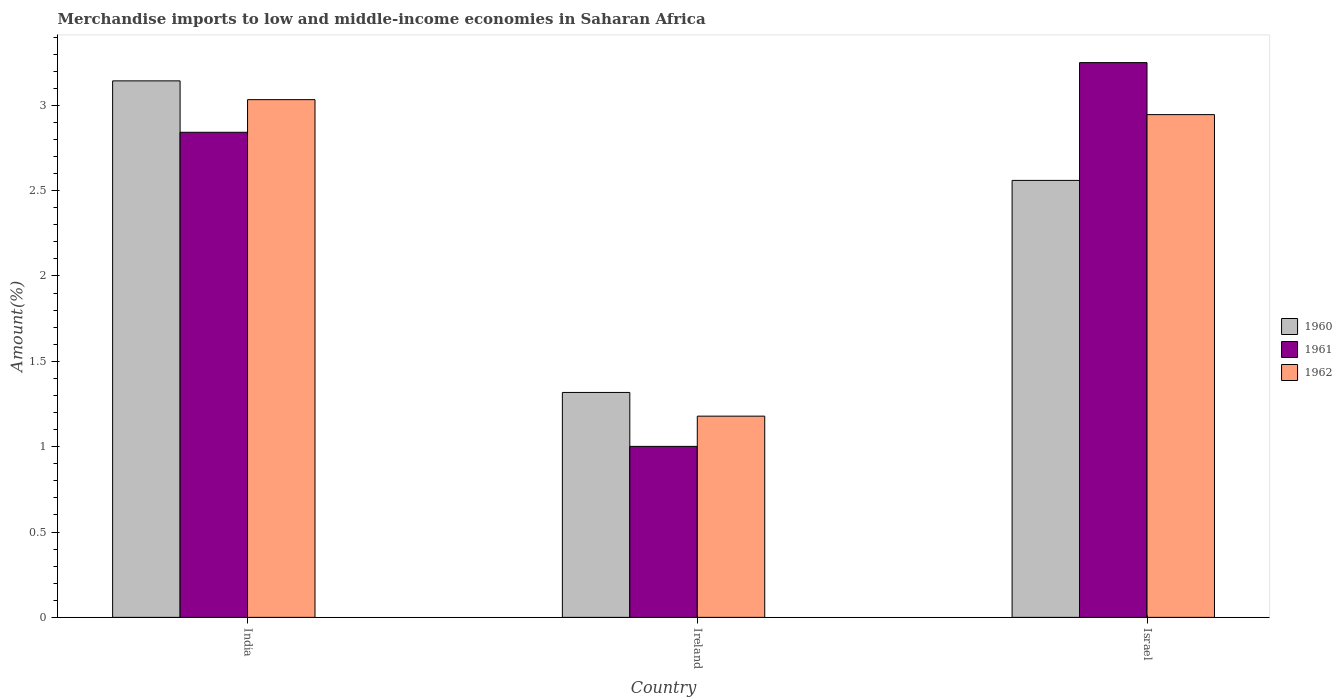How many groups of bars are there?
Offer a terse response. 3. Are the number of bars per tick equal to the number of legend labels?
Your answer should be very brief. Yes. Are the number of bars on each tick of the X-axis equal?
Ensure brevity in your answer.  Yes. How many bars are there on the 3rd tick from the right?
Offer a very short reply. 3. What is the label of the 3rd group of bars from the left?
Provide a short and direct response. Israel. In how many cases, is the number of bars for a given country not equal to the number of legend labels?
Keep it short and to the point. 0. What is the percentage of amount earned from merchandise imports in 1961 in Ireland?
Offer a terse response. 1. Across all countries, what is the maximum percentage of amount earned from merchandise imports in 1962?
Your answer should be very brief. 3.03. Across all countries, what is the minimum percentage of amount earned from merchandise imports in 1961?
Your response must be concise. 1. In which country was the percentage of amount earned from merchandise imports in 1962 maximum?
Provide a succinct answer. India. In which country was the percentage of amount earned from merchandise imports in 1961 minimum?
Your answer should be compact. Ireland. What is the total percentage of amount earned from merchandise imports in 1960 in the graph?
Make the answer very short. 7.02. What is the difference between the percentage of amount earned from merchandise imports in 1961 in India and that in Ireland?
Provide a succinct answer. 1.84. What is the difference between the percentage of amount earned from merchandise imports in 1961 in Ireland and the percentage of amount earned from merchandise imports in 1962 in Israel?
Your answer should be compact. -1.94. What is the average percentage of amount earned from merchandise imports in 1960 per country?
Your answer should be very brief. 2.34. What is the difference between the percentage of amount earned from merchandise imports of/in 1960 and percentage of amount earned from merchandise imports of/in 1961 in Israel?
Provide a short and direct response. -0.69. In how many countries, is the percentage of amount earned from merchandise imports in 1960 greater than 0.4 %?
Your answer should be compact. 3. What is the ratio of the percentage of amount earned from merchandise imports in 1960 in Ireland to that in Israel?
Your answer should be very brief. 0.51. What is the difference between the highest and the second highest percentage of amount earned from merchandise imports in 1961?
Your answer should be compact. -1.84. What is the difference between the highest and the lowest percentage of amount earned from merchandise imports in 1962?
Provide a succinct answer. 1.85. Is the sum of the percentage of amount earned from merchandise imports in 1961 in Ireland and Israel greater than the maximum percentage of amount earned from merchandise imports in 1960 across all countries?
Keep it short and to the point. Yes. What does the 3rd bar from the left in Ireland represents?
Make the answer very short. 1962. What does the 1st bar from the right in Israel represents?
Give a very brief answer. 1962. How many bars are there?
Ensure brevity in your answer.  9. Are all the bars in the graph horizontal?
Your response must be concise. No. Does the graph contain any zero values?
Offer a very short reply. No. Where does the legend appear in the graph?
Your answer should be compact. Center right. How are the legend labels stacked?
Ensure brevity in your answer.  Vertical. What is the title of the graph?
Your response must be concise. Merchandise imports to low and middle-income economies in Saharan Africa. What is the label or title of the X-axis?
Offer a very short reply. Country. What is the label or title of the Y-axis?
Provide a short and direct response. Amount(%). What is the Amount(%) in 1960 in India?
Provide a short and direct response. 3.14. What is the Amount(%) in 1961 in India?
Offer a terse response. 2.84. What is the Amount(%) in 1962 in India?
Ensure brevity in your answer.  3.03. What is the Amount(%) in 1960 in Ireland?
Your answer should be very brief. 1.32. What is the Amount(%) of 1961 in Ireland?
Give a very brief answer. 1. What is the Amount(%) in 1962 in Ireland?
Offer a terse response. 1.18. What is the Amount(%) of 1960 in Israel?
Keep it short and to the point. 2.56. What is the Amount(%) of 1961 in Israel?
Your answer should be very brief. 3.25. What is the Amount(%) in 1962 in Israel?
Make the answer very short. 2.95. Across all countries, what is the maximum Amount(%) of 1960?
Your response must be concise. 3.14. Across all countries, what is the maximum Amount(%) in 1961?
Offer a very short reply. 3.25. Across all countries, what is the maximum Amount(%) in 1962?
Offer a very short reply. 3.03. Across all countries, what is the minimum Amount(%) in 1960?
Make the answer very short. 1.32. Across all countries, what is the minimum Amount(%) in 1961?
Provide a succinct answer. 1. Across all countries, what is the minimum Amount(%) of 1962?
Make the answer very short. 1.18. What is the total Amount(%) in 1960 in the graph?
Your response must be concise. 7.02. What is the total Amount(%) of 1961 in the graph?
Offer a very short reply. 7.09. What is the total Amount(%) of 1962 in the graph?
Provide a succinct answer. 7.16. What is the difference between the Amount(%) in 1960 in India and that in Ireland?
Provide a succinct answer. 1.83. What is the difference between the Amount(%) of 1961 in India and that in Ireland?
Your response must be concise. 1.84. What is the difference between the Amount(%) in 1962 in India and that in Ireland?
Keep it short and to the point. 1.85. What is the difference between the Amount(%) of 1960 in India and that in Israel?
Your answer should be compact. 0.58. What is the difference between the Amount(%) of 1961 in India and that in Israel?
Give a very brief answer. -0.41. What is the difference between the Amount(%) of 1962 in India and that in Israel?
Your answer should be very brief. 0.09. What is the difference between the Amount(%) of 1960 in Ireland and that in Israel?
Ensure brevity in your answer.  -1.24. What is the difference between the Amount(%) in 1961 in Ireland and that in Israel?
Offer a terse response. -2.25. What is the difference between the Amount(%) in 1962 in Ireland and that in Israel?
Provide a short and direct response. -1.77. What is the difference between the Amount(%) in 1960 in India and the Amount(%) in 1961 in Ireland?
Keep it short and to the point. 2.14. What is the difference between the Amount(%) of 1960 in India and the Amount(%) of 1962 in Ireland?
Give a very brief answer. 1.96. What is the difference between the Amount(%) of 1961 in India and the Amount(%) of 1962 in Ireland?
Your answer should be very brief. 1.66. What is the difference between the Amount(%) of 1960 in India and the Amount(%) of 1961 in Israel?
Give a very brief answer. -0.11. What is the difference between the Amount(%) of 1960 in India and the Amount(%) of 1962 in Israel?
Provide a succinct answer. 0.2. What is the difference between the Amount(%) in 1961 in India and the Amount(%) in 1962 in Israel?
Your answer should be very brief. -0.1. What is the difference between the Amount(%) in 1960 in Ireland and the Amount(%) in 1961 in Israel?
Offer a very short reply. -1.93. What is the difference between the Amount(%) of 1960 in Ireland and the Amount(%) of 1962 in Israel?
Offer a very short reply. -1.63. What is the difference between the Amount(%) in 1961 in Ireland and the Amount(%) in 1962 in Israel?
Ensure brevity in your answer.  -1.94. What is the average Amount(%) of 1960 per country?
Give a very brief answer. 2.34. What is the average Amount(%) of 1961 per country?
Give a very brief answer. 2.36. What is the average Amount(%) in 1962 per country?
Offer a terse response. 2.39. What is the difference between the Amount(%) of 1960 and Amount(%) of 1961 in India?
Offer a very short reply. 0.3. What is the difference between the Amount(%) in 1960 and Amount(%) in 1962 in India?
Provide a succinct answer. 0.11. What is the difference between the Amount(%) of 1961 and Amount(%) of 1962 in India?
Your answer should be very brief. -0.19. What is the difference between the Amount(%) of 1960 and Amount(%) of 1961 in Ireland?
Your answer should be very brief. 0.32. What is the difference between the Amount(%) of 1960 and Amount(%) of 1962 in Ireland?
Keep it short and to the point. 0.14. What is the difference between the Amount(%) in 1961 and Amount(%) in 1962 in Ireland?
Offer a very short reply. -0.18. What is the difference between the Amount(%) of 1960 and Amount(%) of 1961 in Israel?
Your answer should be very brief. -0.69. What is the difference between the Amount(%) of 1960 and Amount(%) of 1962 in Israel?
Your answer should be very brief. -0.39. What is the difference between the Amount(%) of 1961 and Amount(%) of 1962 in Israel?
Offer a very short reply. 0.3. What is the ratio of the Amount(%) in 1960 in India to that in Ireland?
Provide a short and direct response. 2.39. What is the ratio of the Amount(%) in 1961 in India to that in Ireland?
Your answer should be very brief. 2.84. What is the ratio of the Amount(%) of 1962 in India to that in Ireland?
Offer a terse response. 2.57. What is the ratio of the Amount(%) in 1960 in India to that in Israel?
Ensure brevity in your answer.  1.23. What is the ratio of the Amount(%) of 1961 in India to that in Israel?
Your answer should be compact. 0.87. What is the ratio of the Amount(%) in 1962 in India to that in Israel?
Your response must be concise. 1.03. What is the ratio of the Amount(%) of 1960 in Ireland to that in Israel?
Keep it short and to the point. 0.51. What is the ratio of the Amount(%) of 1961 in Ireland to that in Israel?
Make the answer very short. 0.31. What is the ratio of the Amount(%) in 1962 in Ireland to that in Israel?
Provide a short and direct response. 0.4. What is the difference between the highest and the second highest Amount(%) of 1960?
Provide a succinct answer. 0.58. What is the difference between the highest and the second highest Amount(%) in 1961?
Your response must be concise. 0.41. What is the difference between the highest and the second highest Amount(%) in 1962?
Ensure brevity in your answer.  0.09. What is the difference between the highest and the lowest Amount(%) of 1960?
Provide a succinct answer. 1.83. What is the difference between the highest and the lowest Amount(%) in 1961?
Provide a succinct answer. 2.25. What is the difference between the highest and the lowest Amount(%) in 1962?
Your response must be concise. 1.85. 